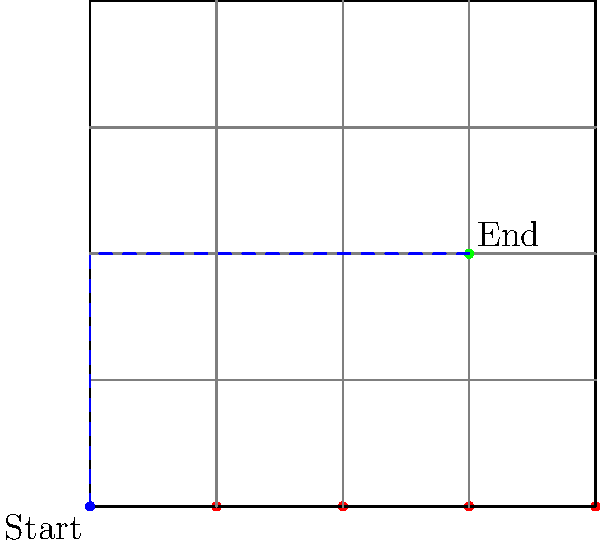In a 5x5 grid representing city blocks, you need to navigate from the bottom-left corner (0,0) to a point at coordinates (3,2). What is the minimum number of steps required to reach the destination, assuming you can only move horizontally or vertically? Let's approach this step-by-step, using a method similar to Manhattan distance calculation:

1) In grid-based pathfinding, the shortest path is often calculated using the Manhattan distance, which is the sum of the horizontal and vertical distances.

2) To move from (0,0) to (3,2):
   - Horizontal distance: 3 steps to the right
   - Vertical distance: 2 steps up

3) The total number of steps is the sum of these distances:
   $$\text{Total steps} = \text{Horizontal steps} + \text{Vertical steps}$$
   $$\text{Total steps} = 3 + 2 = 5$$

4) This approach guarantees the shortest path because:
   - Any path that deviates from this direct route would require additional steps.
   - There are multiple paths that achieve this minimum (e.g., right-right-right-up-up or up-up-right-right-right), but all have the same number of steps.

5) This method is analogous to the Manhattan distance calculation in taxi-cab geometry, which is often used in grid-based pathfinding algorithms in software development.
Answer: 5 steps 